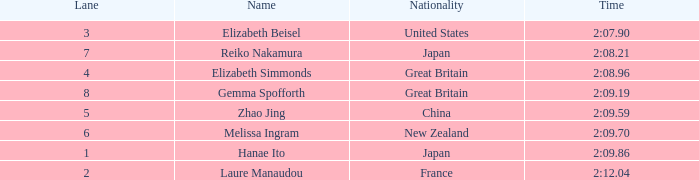What is the top position attained by laure manaudou in her career? 8.0. Can you parse all the data within this table? {'header': ['Lane', 'Name', 'Nationality', 'Time'], 'rows': [['3', 'Elizabeth Beisel', 'United States', '2:07.90'], ['7', 'Reiko Nakamura', 'Japan', '2:08.21'], ['4', 'Elizabeth Simmonds', 'Great Britain', '2:08.96'], ['8', 'Gemma Spofforth', 'Great Britain', '2:09.19'], ['5', 'Zhao Jing', 'China', '2:09.59'], ['6', 'Melissa Ingram', 'New Zealand', '2:09.70'], ['1', 'Hanae Ito', 'Japan', '2:09.86'], ['2', 'Laure Manaudou', 'France', '2:12.04']]} 